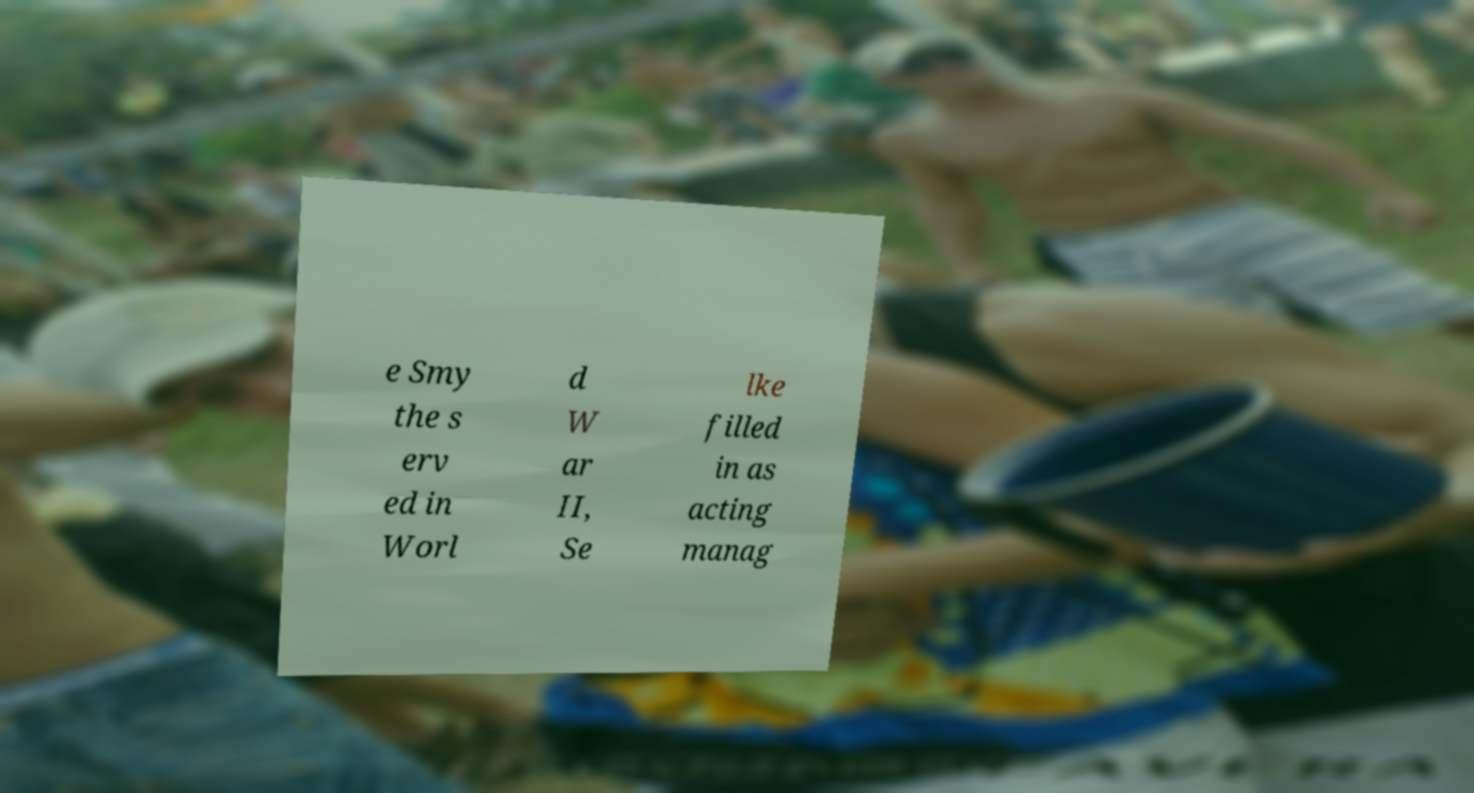I need the written content from this picture converted into text. Can you do that? e Smy the s erv ed in Worl d W ar II, Se lke filled in as acting manag 